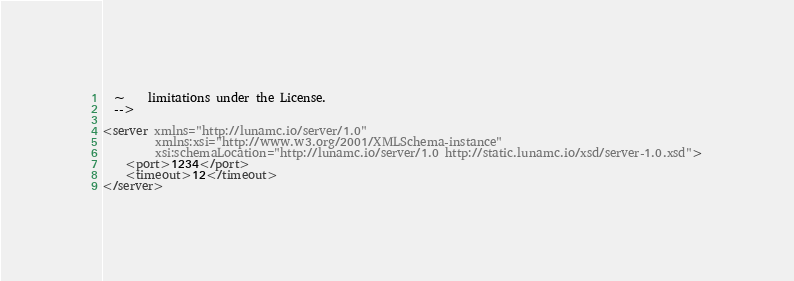Convert code to text. <code><loc_0><loc_0><loc_500><loc_500><_XML_>  ~    limitations under the License.
  -->

<server xmlns="http://lunamc.io/server/1.0"
         xmlns:xsi="http://www.w3.org/2001/XMLSchema-instance"
         xsi:schemaLocation="http://lunamc.io/server/1.0 http://static.lunamc.io/xsd/server-1.0.xsd">
    <port>1234</port>
    <timeout>12</timeout>
</server>
</code> 